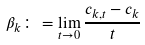Convert formula to latex. <formula><loc_0><loc_0><loc_500><loc_500>\beta _ { k } \colon = \lim _ { t \to 0 } \frac { c _ { k , t } - c _ { k } } { t }</formula> 